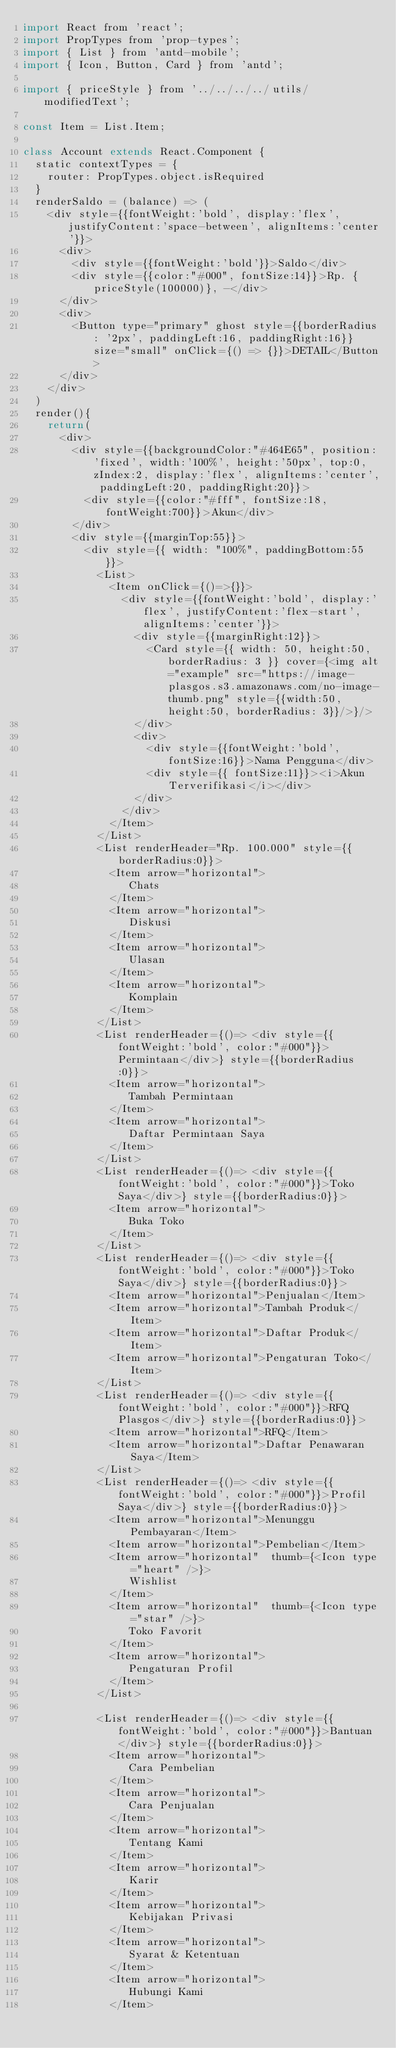Convert code to text. <code><loc_0><loc_0><loc_500><loc_500><_JavaScript_>import React from 'react';
import PropTypes from 'prop-types';
import { List } from 'antd-mobile';
import { Icon, Button, Card } from 'antd';

import { priceStyle } from '../../../../utils/modifiedText';

const Item = List.Item;

class Account extends React.Component {
  static contextTypes = {
    router: PropTypes.object.isRequired
  }
  renderSaldo = (balance) => (
    <div style={{fontWeight:'bold', display:'flex', justifyContent:'space-between', alignItems:'center'}}>
      <div>
        <div style={{fontWeight:'bold'}}>Saldo</div>
        <div style={{color:"#000", fontSize:14}}>Rp. {priceStyle(100000)}, -</div>
      </div>
      <div>
        <Button type="primary" ghost style={{borderRadius: '2px', paddingLeft:16, paddingRight:16}} size="small" onClick={() => {}}>DETAIL</Button>
      </div>
    </div>
  )
  render(){
    return(
      <div>
        <div style={{backgroundColor:"#464E65", position:'fixed', width:'100%', height:'50px', top:0, zIndex:2, display:'flex', alignItems:'center', paddingLeft:20, paddingRight:20}}>
          <div style={{color:"#fff", fontSize:18, fontWeight:700}}>Akun</div>
        </div>
        <div style={{marginTop:55}}>
          <div style={{ width: "100%", paddingBottom:55 }}>
            <List>
              <Item onClick={()=>{}}>
                <div style={{fontWeight:'bold', display:'flex', justifyContent:'flex-start', alignItems:'center'}}>
                  <div style={{marginRight:12}}>
                    <Card style={{ width: 50, height:50, borderRadius: 3 }} cover={<img alt="example" src="https://image-plasgos.s3.amazonaws.com/no-image-thumb.png" style={{width:50, height:50, borderRadius: 3}}/>}/>
                  </div>
                  <div>
                    <div style={{fontWeight:'bold', fontSize:16}}>Nama Pengguna</div>
                    <div style={{ fontSize:11}}><i>Akun Terverifikasi</i></div>
                  </div>
                </div>
              </Item>
            </List>
            <List renderHeader="Rp. 100.000" style={{borderRadius:0}}>
              <Item arrow="horizontal">
                 Chats
              </Item>
              <Item arrow="horizontal">
                 Diskusi
              </Item>
              <Item arrow="horizontal">
                 Ulasan
              </Item>
              <Item arrow="horizontal">
                 Komplain
              </Item>
            </List>
            <List renderHeader={()=> <div style={{fontWeight:'bold', color:"#000"}}>Permintaan</div>} style={{borderRadius:0}}>
              <Item arrow="horizontal">
                 Tambah Permintaan
              </Item>
              <Item arrow="horizontal">
                 Daftar Permintaan Saya
              </Item>
            </List>
            <List renderHeader={()=> <div style={{fontWeight:'bold', color:"#000"}}>Toko Saya</div>} style={{borderRadius:0}}>
              <Item arrow="horizontal">
                 Buka Toko
              </Item>
            </List>
            <List renderHeader={()=> <div style={{fontWeight:'bold', color:"#000"}}>Toko Saya</div>} style={{borderRadius:0}}>
              <Item arrow="horizontal">Penjualan</Item>
              <Item arrow="horizontal">Tambah Produk</Item>
              <Item arrow="horizontal">Daftar Produk</Item>
              <Item arrow="horizontal">Pengaturan Toko</Item>
            </List>
            <List renderHeader={()=> <div style={{fontWeight:'bold', color:"#000"}}>RFQ Plasgos</div>} style={{borderRadius:0}}>
              <Item arrow="horizontal">RFQ</Item>
              <Item arrow="horizontal">Daftar Penawaran Saya</Item>
            </List>
            <List renderHeader={()=> <div style={{fontWeight:'bold', color:"#000"}}>Profil Saya</div>} style={{borderRadius:0}}>
              <Item arrow="horizontal">Menunggu Pembayaran</Item>
              <Item arrow="horizontal">Pembelian</Item>
              <Item arrow="horizontal"  thumb={<Icon type="heart" />}>
                 Wishlist
              </Item>
              <Item arrow="horizontal"  thumb={<Icon type="star" />}>
                 Toko Favorit
              </Item>
              <Item arrow="horizontal">
                 Pengaturan Profil
              </Item>
            </List>

            <List renderHeader={()=> <div style={{fontWeight:'bold', color:"#000"}}>Bantuan</div>} style={{borderRadius:0}}>
              <Item arrow="horizontal">
                 Cara Pembelian
              </Item>
              <Item arrow="horizontal">
                 Cara Penjualan
              </Item>
              <Item arrow="horizontal">
                 Tentang Kami
              </Item>
              <Item arrow="horizontal">
                 Karir
              </Item>
              <Item arrow="horizontal">
                 Kebijakan Privasi
              </Item>
              <Item arrow="horizontal">
                 Syarat & Ketentuan
              </Item>
              <Item arrow="horizontal">
                 Hubungi Kami
              </Item></code> 